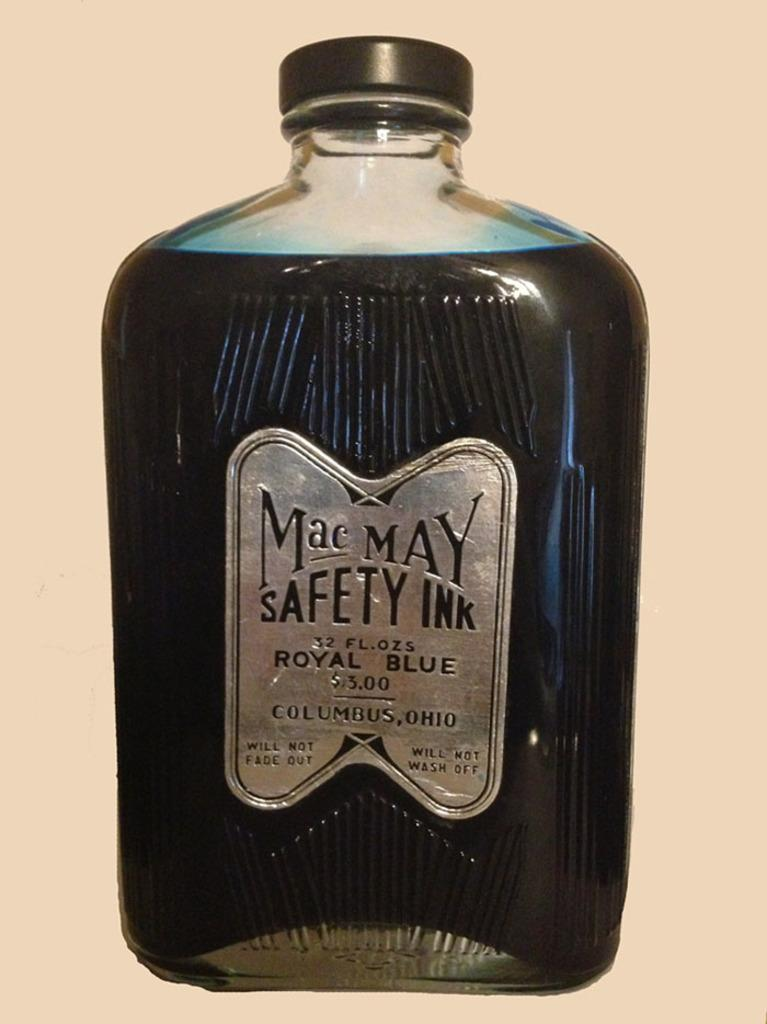Provide a one-sentence caption for the provided image. a close up of Mac May Safety Ink in royal blue. 